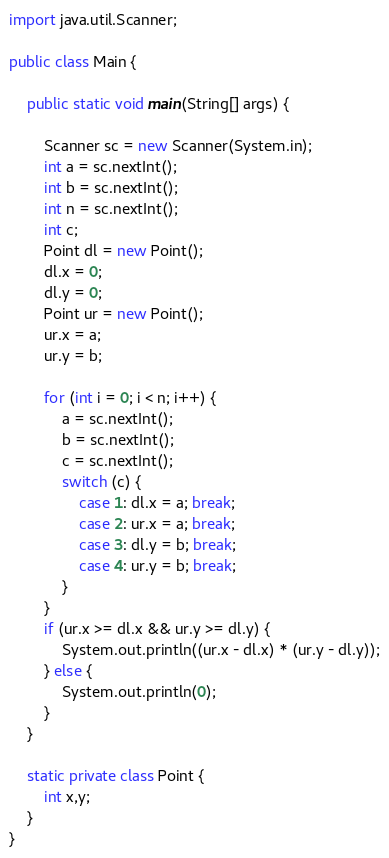<code> <loc_0><loc_0><loc_500><loc_500><_Java_>
import java.util.Scanner;
 
public class Main {
 
    public static void main(String[] args) {
 
        Scanner sc = new Scanner(System.in);
        int a = sc.nextInt();
        int b = sc.nextInt();
        int n = sc.nextInt();
        int c;
        Point dl = new Point();
        dl.x = 0;
        dl.y = 0;
        Point ur = new Point();
        ur.x = a;
        ur.y = b;
 
        for (int i = 0; i < n; i++) {
            a = sc.nextInt();
            b = sc.nextInt();
            c = sc.nextInt();
            switch (c) {
                case 1: dl.x = a; break;
                case 2: ur.x = a; break;
                case 3: dl.y = b; break;
                case 4: ur.y = b; break;
            }
        }
        if (ur.x >= dl.x && ur.y >= dl.y) {
            System.out.println((ur.x - dl.x) * (ur.y - dl.y));
        } else {
            System.out.println(0);
        }
    }
 
    static private class Point {
        int x,y;
    }
}</code> 